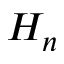Convert formula to latex. <formula><loc_0><loc_0><loc_500><loc_500>H _ { n }</formula> 